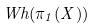<formula> <loc_0><loc_0><loc_500><loc_500>W h ( \pi _ { 1 } ( X ) )</formula> 